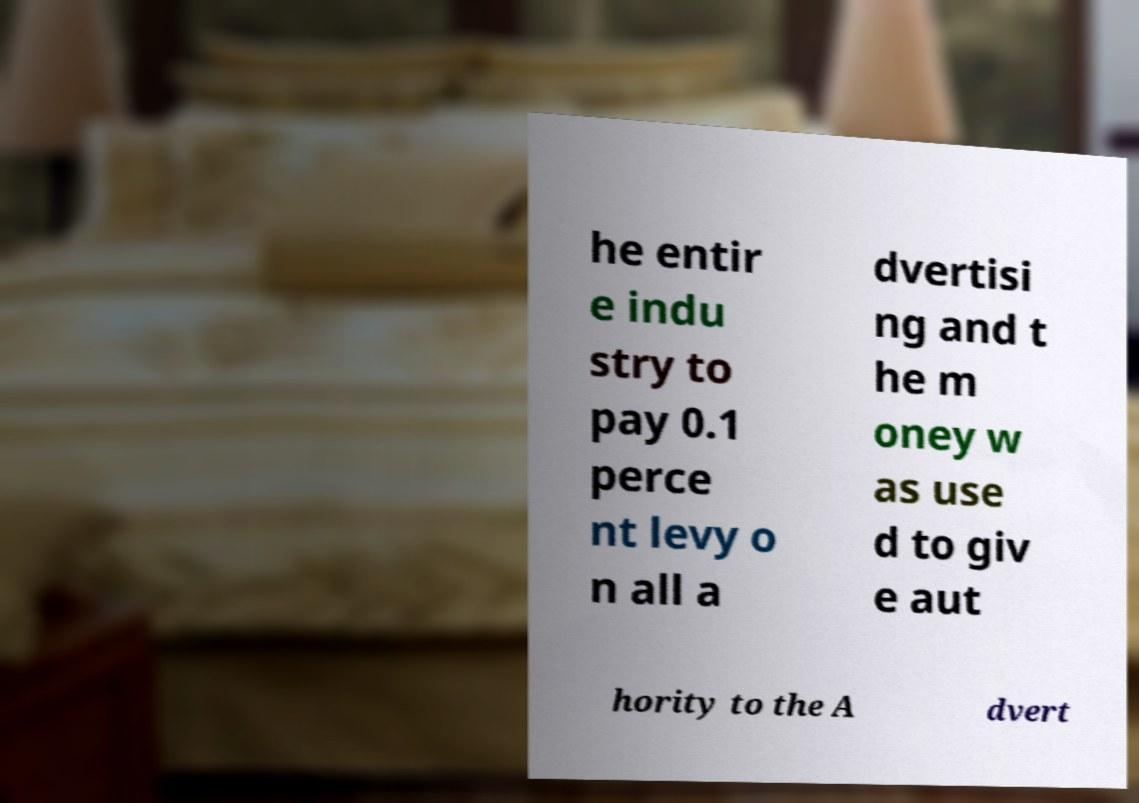Could you assist in decoding the text presented in this image and type it out clearly? he entir e indu stry to pay 0.1 perce nt levy o n all a dvertisi ng and t he m oney w as use d to giv e aut hority to the A dvert 